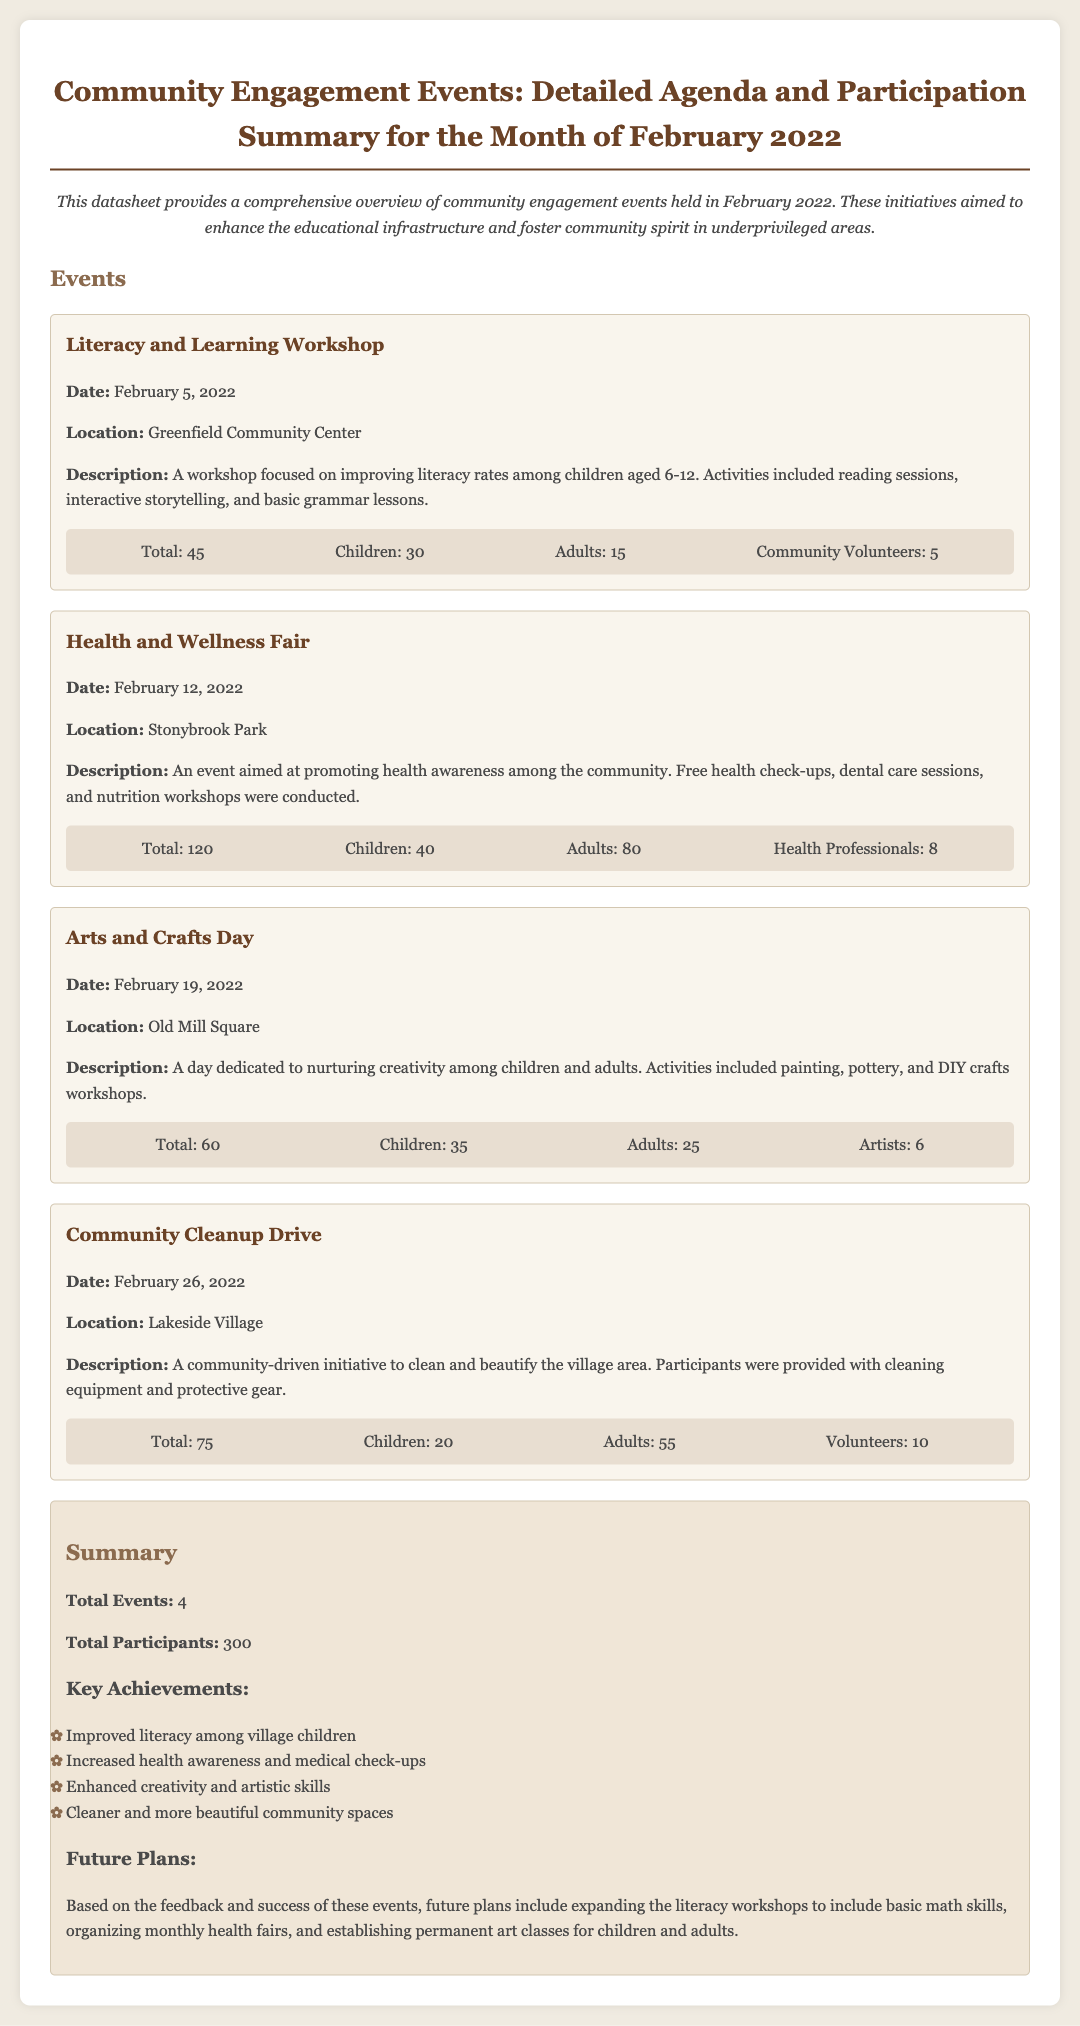What is the date of the Literacy and Learning Workshop? The date can be found in the section describing the event, which states it is on February 5, 2022.
Answer: February 5, 2022 How many total participants attended the Health and Wellness Fair? The participant count is mentioned under the event details, showing that 120 individuals attended the fair.
Answer: 120 What location hosted the Arts and Crafts Day? The location for the Arts and Crafts Day is listed in the event description as Old Mill Square.
Answer: Old Mill Square What is one of the key achievements mentioned in the summary? The key achievements can be found in the summary section where specific accomplishments such as improved literacy are highlighted.
Answer: Improved literacy among village children How many events took place in February 2022? The total number of events is summarized at the end of the document, indicating that there were 4 events held.
Answer: 4 What type of professionals participated in the Health and Wellness Fair? The event description mentions that health professionals were involved, specifically noting the quantity during the participants section.
Answer: Health Professionals What future plan involves math skills? In the future plans section, it refers to expanding literacy workshops to include basic math skills.
Answer: Basic math skills How many adults participated in the Community Cleanup Drive? The details under the Community Cleanup Drive event specify that there were 55 adults participating.
Answer: 55 What was the total number of children across all events? To find the total, you must add the number of children from each event, which is 30 + 40 + 35 + 20 = 125.
Answer: 125 